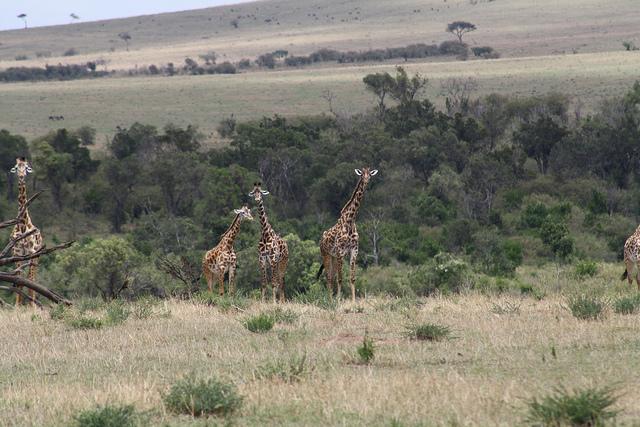How many animals are shown?
Give a very brief answer. 5. Sunny or overcast?
Be succinct. Sunny. Are the animals all the same type?
Keep it brief. Yes. How many giraffes are there?
Keep it brief. 5. What color is the grass?
Give a very brief answer. Green. 